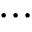<formula> <loc_0><loc_0><loc_500><loc_500>\cdots</formula> 